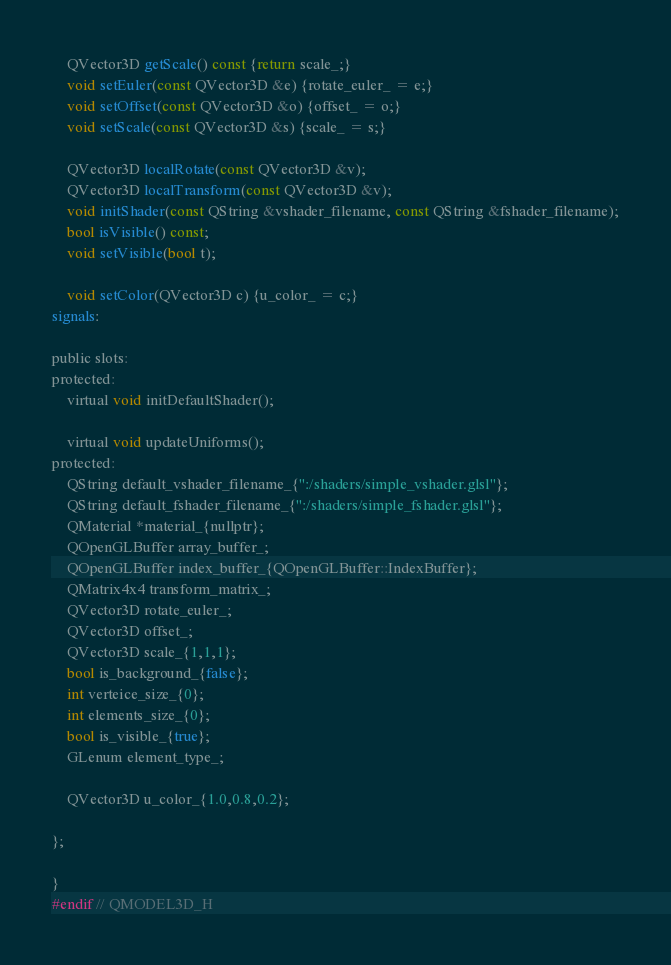<code> <loc_0><loc_0><loc_500><loc_500><_C_>    QVector3D getScale() const {return scale_;}
    void setEuler(const QVector3D &e) {rotate_euler_ = e;}
    void setOffset(const QVector3D &o) {offset_ = o;}
    void setScale(const QVector3D &s) {scale_ = s;}

    QVector3D localRotate(const QVector3D &v);
    QVector3D localTransform(const QVector3D &v);
    void initShader(const QString &vshader_filename, const QString &fshader_filename);
    bool isVisible() const;
    void setVisible(bool t);

    void setColor(QVector3D c) {u_color_ = c;}
signals:

public slots:
protected:
    virtual void initDefaultShader();

    virtual void updateUniforms();
protected:
    QString default_vshader_filename_{":/shaders/simple_vshader.glsl"};
    QString default_fshader_filename_{":/shaders/simple_fshader.glsl"};
    QMaterial *material_{nullptr};
    QOpenGLBuffer array_buffer_;
    QOpenGLBuffer index_buffer_{QOpenGLBuffer::IndexBuffer};
    QMatrix4x4 transform_matrix_;
    QVector3D rotate_euler_;
    QVector3D offset_;
    QVector3D scale_{1,1,1};
    bool is_background_{false};
    int verteice_size_{0};
    int elements_size_{0};
    bool is_visible_{true};
    GLenum element_type_;

    QVector3D u_color_{1.0,0.8,0.2};

};

}
#endif // QMODEL3D_H
</code> 